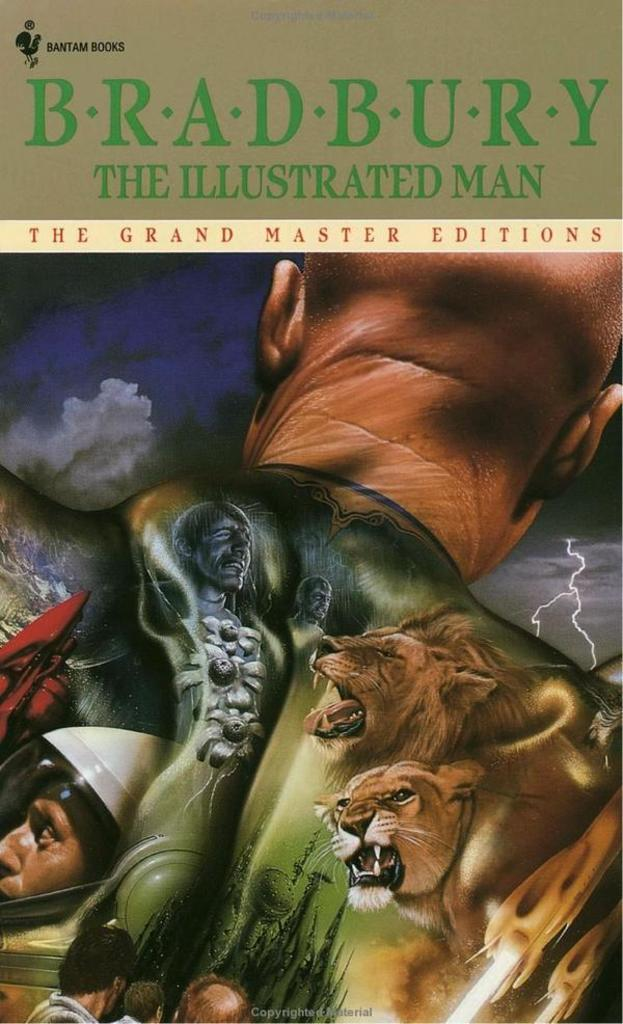What is the main subject in the image? There is a poster in the image. What type of authority figure is running away from the poster in the image? There is no authority figure or running depicted in the image; it only features a poster. 